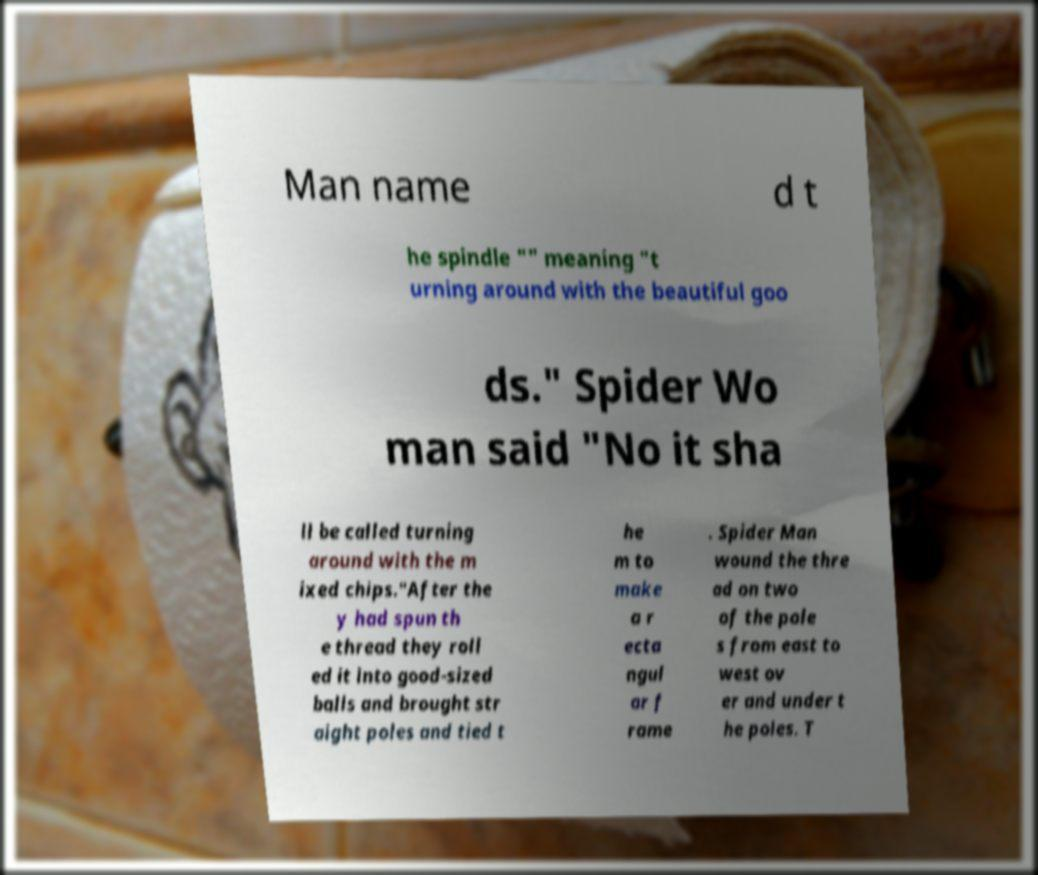Can you accurately transcribe the text from the provided image for me? Man name d t he spindle "" meaning "t urning around with the beautiful goo ds." Spider Wo man said "No it sha ll be called turning around with the m ixed chips."After the y had spun th e thread they roll ed it into good-sized balls and brought str aight poles and tied t he m to make a r ecta ngul ar f rame . Spider Man wound the thre ad on two of the pole s from east to west ov er and under t he poles. T 